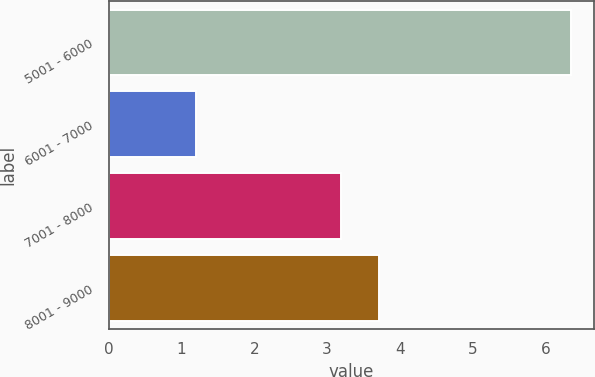Convert chart to OTSL. <chart><loc_0><loc_0><loc_500><loc_500><bar_chart><fcel>5001 - 6000<fcel>6001 - 7000<fcel>7001 - 8000<fcel>8001 - 9000<nl><fcel>6.35<fcel>1.2<fcel>3.19<fcel>3.71<nl></chart> 